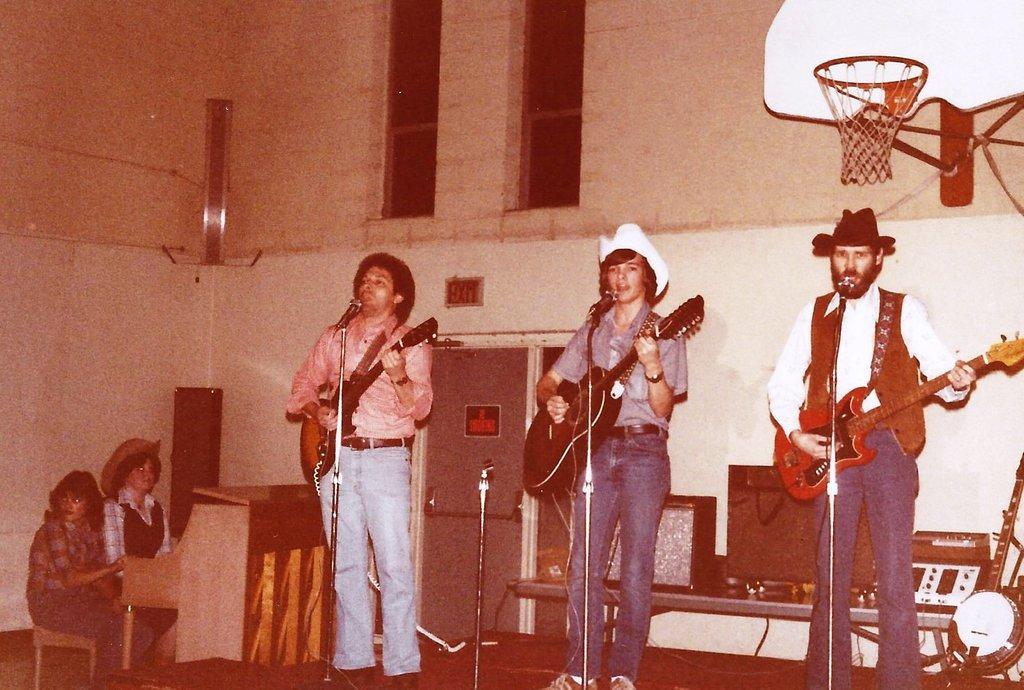How would you summarize this image in a sentence or two? In this image, There are some people standing and they are holding some music instruments and there are some microphones which are in black color, In the left side there are some people sitting on the chairs and they are paying a piano, In the top in the right side there is a basket which is in brown color, There is a wall which is in white color. 